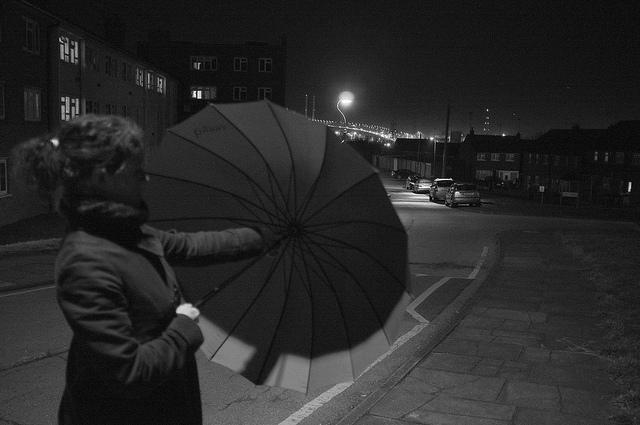Does this lady need to use her umbrella?
Keep it brief. No. Who is standing on the tarmac?
Be succinct. Woman. Is it windy?
Quick response, please. Yes. Do the weather appear to be cold?
Concise answer only. Yes. What color is the umbrella?
Keep it brief. Black. 